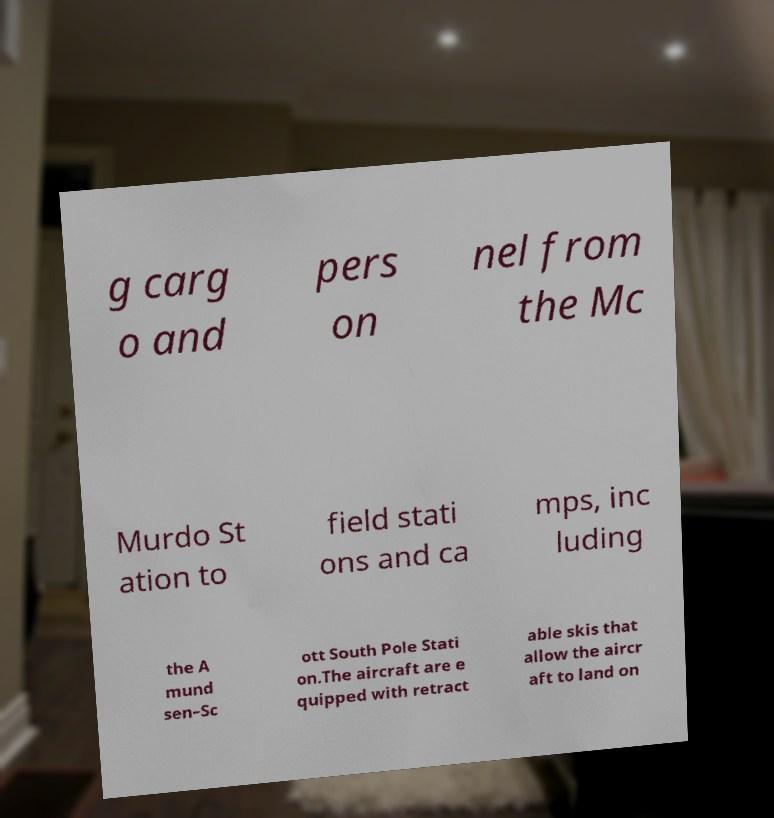There's text embedded in this image that I need extracted. Can you transcribe it verbatim? g carg o and pers on nel from the Mc Murdo St ation to field stati ons and ca mps, inc luding the A mund sen–Sc ott South Pole Stati on.The aircraft are e quipped with retract able skis that allow the aircr aft to land on 